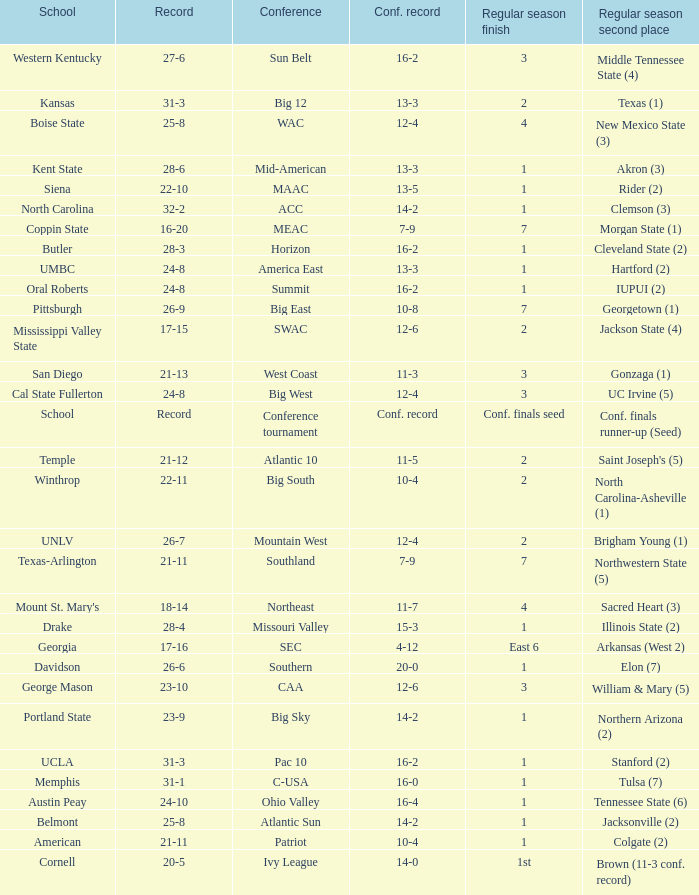For teams in the Sun Belt conference, what is the conference record? 16-2. Could you parse the entire table? {'header': ['School', 'Record', 'Conference', 'Conf. record', 'Regular season finish', 'Regular season second place'], 'rows': [['Western Kentucky', '27-6', 'Sun Belt', '16-2', '3', 'Middle Tennessee State (4)'], ['Kansas', '31-3', 'Big 12', '13-3', '2', 'Texas (1)'], ['Boise State', '25-8', 'WAC', '12-4', '4', 'New Mexico State (3)'], ['Kent State', '28-6', 'Mid-American', '13-3', '1', 'Akron (3)'], ['Siena', '22-10', 'MAAC', '13-5', '1', 'Rider (2)'], ['North Carolina', '32-2', 'ACC', '14-2', '1', 'Clemson (3)'], ['Coppin State', '16-20', 'MEAC', '7-9', '7', 'Morgan State (1)'], ['Butler', '28-3', 'Horizon', '16-2', '1', 'Cleveland State (2)'], ['UMBC', '24-8', 'America East', '13-3', '1', 'Hartford (2)'], ['Oral Roberts', '24-8', 'Summit', '16-2', '1', 'IUPUI (2)'], ['Pittsburgh', '26-9', 'Big East', '10-8', '7', 'Georgetown (1)'], ['Mississippi Valley State', '17-15', 'SWAC', '12-6', '2', 'Jackson State (4)'], ['San Diego', '21-13', 'West Coast', '11-3', '3', 'Gonzaga (1)'], ['Cal State Fullerton', '24-8', 'Big West', '12-4', '3', 'UC Irvine (5)'], ['School', 'Record', 'Conference tournament', 'Conf. record', 'Conf. finals seed', 'Conf. finals runner-up (Seed)'], ['Temple', '21-12', 'Atlantic 10', '11-5', '2', "Saint Joseph's (5)"], ['Winthrop', '22-11', 'Big South', '10-4', '2', 'North Carolina-Asheville (1)'], ['UNLV', '26-7', 'Mountain West', '12-4', '2', 'Brigham Young (1)'], ['Texas-Arlington', '21-11', 'Southland', '7-9', '7', 'Northwestern State (5)'], ["Mount St. Mary's", '18-14', 'Northeast', '11-7', '4', 'Sacred Heart (3)'], ['Drake', '28-4', 'Missouri Valley', '15-3', '1', 'Illinois State (2)'], ['Georgia', '17-16', 'SEC', '4-12', 'East 6', 'Arkansas (West 2)'], ['Davidson', '26-6', 'Southern', '20-0', '1', 'Elon (7)'], ['George Mason', '23-10', 'CAA', '12-6', '3', 'William & Mary (5)'], ['Portland State', '23-9', 'Big Sky', '14-2', '1', 'Northern Arizona (2)'], ['UCLA', '31-3', 'Pac 10', '16-2', '1', 'Stanford (2)'], ['Memphis', '31-1', 'C-USA', '16-0', '1', 'Tulsa (7)'], ['Austin Peay', '24-10', 'Ohio Valley', '16-4', '1', 'Tennessee State (6)'], ['Belmont', '25-8', 'Atlantic Sun', '14-2', '1', 'Jacksonville (2)'], ['American', '21-11', 'Patriot', '10-4', '1', 'Colgate (2)'], ['Cornell', '20-5', 'Ivy League', '14-0', '1st', 'Brown (11-3 conf. record)']]} 